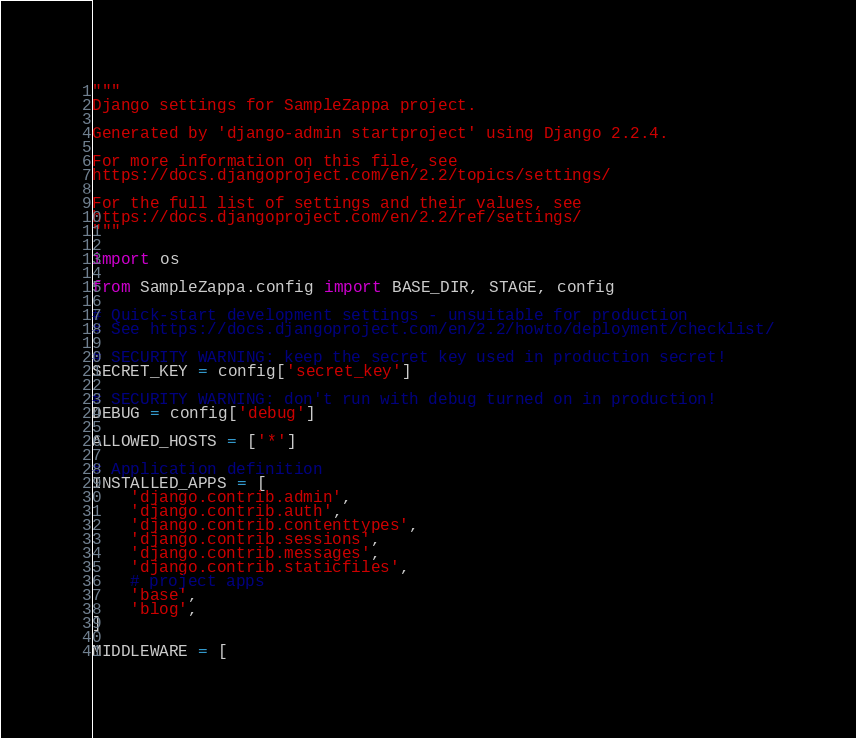Convert code to text. <code><loc_0><loc_0><loc_500><loc_500><_Python_>"""
Django settings for SampleZappa project.

Generated by 'django-admin startproject' using Django 2.2.4.

For more information on this file, see
https://docs.djangoproject.com/en/2.2/topics/settings/

For the full list of settings and their values, see
https://docs.djangoproject.com/en/2.2/ref/settings/
"""

import os

from SampleZappa.config import BASE_DIR, STAGE, config

# Quick-start development settings - unsuitable for production
# See https://docs.djangoproject.com/en/2.2/howto/deployment/checklist/

# SECURITY WARNING: keep the secret key used in production secret!
SECRET_KEY = config['secret_key']

# SECURITY WARNING: don't run with debug turned on in production!
DEBUG = config['debug']

ALLOWED_HOSTS = ['*']

# Application definition
INSTALLED_APPS = [
    'django.contrib.admin',
    'django.contrib.auth',
    'django.contrib.contenttypes',
    'django.contrib.sessions',
    'django.contrib.messages',
    'django.contrib.staticfiles',
    # project apps
    'base',
    'blog',
]

MIDDLEWARE = [</code> 